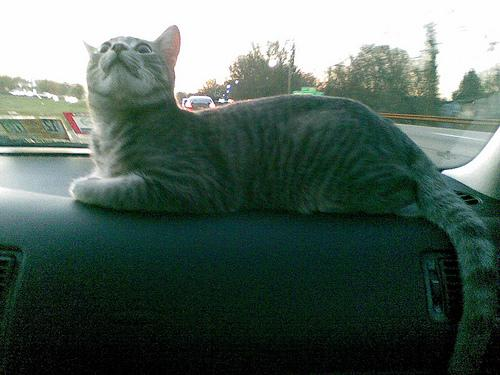Question: why is the tail lights red on the car in front?
Choices:
A. The car stopped.
B. The car is breaking.
C. It is slowing.
D. The breaks are pressed.
Answer with the letter. Answer: B Question: what is the cat doing?
Choices:
A. Sleeping.
B. Yawning.
C. Sitting.
D. Meowing.
Answer with the letter. Answer: C Question: what direction is the cat looking?
Choices:
A. Right.
B. Looking up.
C. Down.
D. To the left.
Answer with the letter. Answer: B 